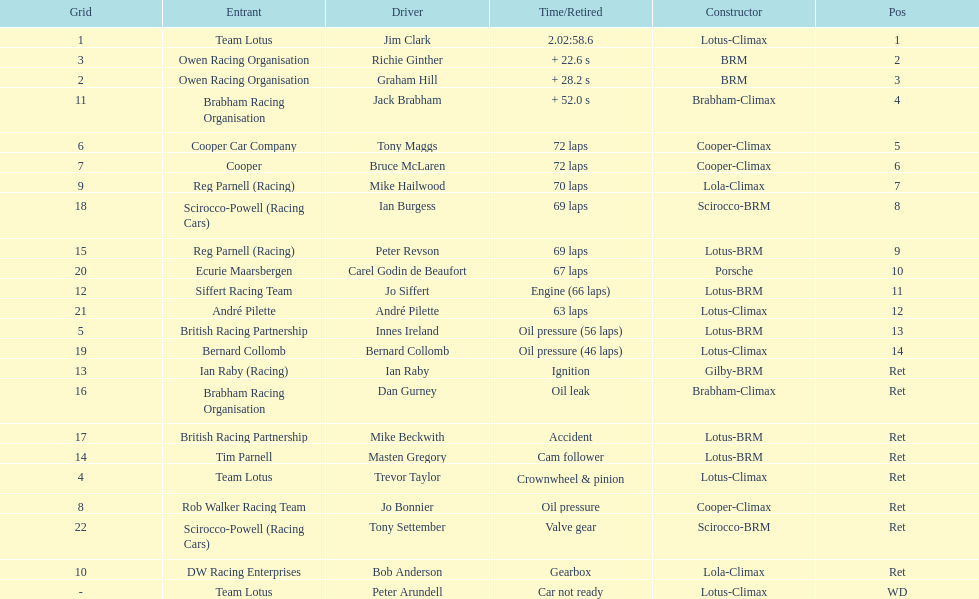What was the same problem that bernard collomb had as innes ireland? Oil pressure. 